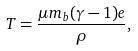<formula> <loc_0><loc_0><loc_500><loc_500>T = \frac { \mu m _ { b } ( \gamma - 1 ) e } { \rho } ,</formula> 